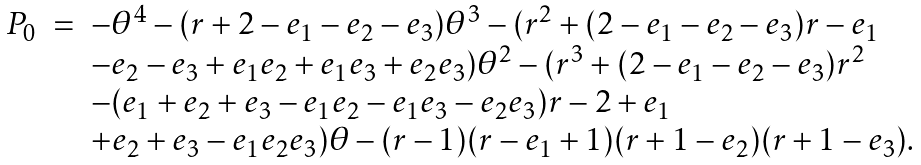Convert formula to latex. <formula><loc_0><loc_0><loc_500><loc_500>\begin{array} { l c l } P _ { 0 } & = & - \theta ^ { 4 } - ( r + 2 - e _ { 1 } - e _ { 2 } - e _ { 3 } ) \theta ^ { 3 } - ( r ^ { 2 } + ( 2 - e _ { 1 } - e _ { 2 } - e _ { 3 } ) r - e _ { 1 } \\ & & - e _ { 2 } - e _ { 3 } + e _ { 1 } e _ { 2 } + e _ { 1 } e _ { 3 } + e _ { 2 } e _ { 3 } ) \theta ^ { 2 } - ( r ^ { 3 } + ( 2 - e _ { 1 } - e _ { 2 } - e _ { 3 } ) r ^ { 2 } \\ & & - ( e _ { 1 } + e _ { 2 } + e _ { 3 } - e _ { 1 } e _ { 2 } - e _ { 1 } e _ { 3 } - e _ { 2 } e _ { 3 } ) r - 2 + e _ { 1 } \\ & & + e _ { 2 } + e _ { 3 } - e _ { 1 } e _ { 2 } e _ { 3 } ) \theta - ( r - 1 ) ( r - e _ { 1 } + 1 ) ( r + 1 - e _ { 2 } ) ( r + 1 - e _ { 3 } ) . \end{array}</formula> 